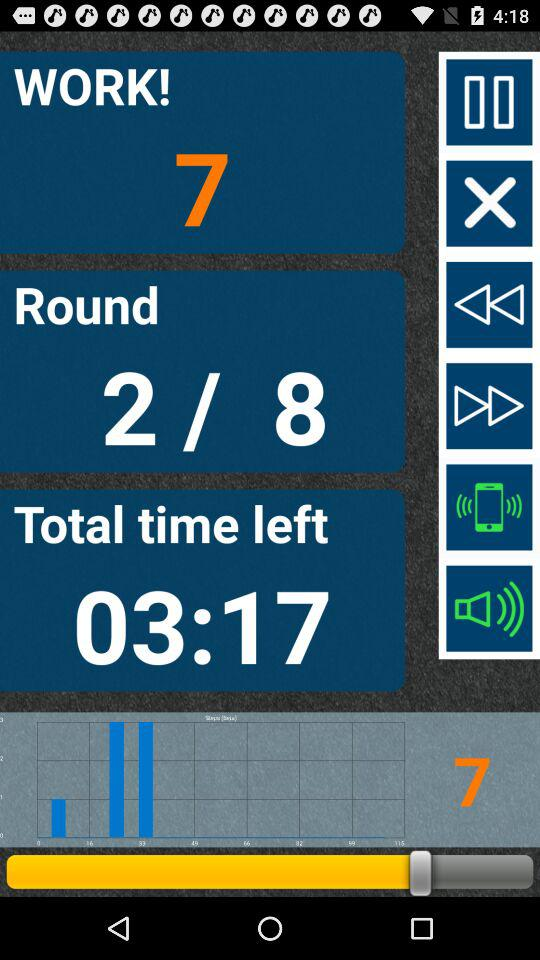How many total rounds are there? There are 8 rounds. 